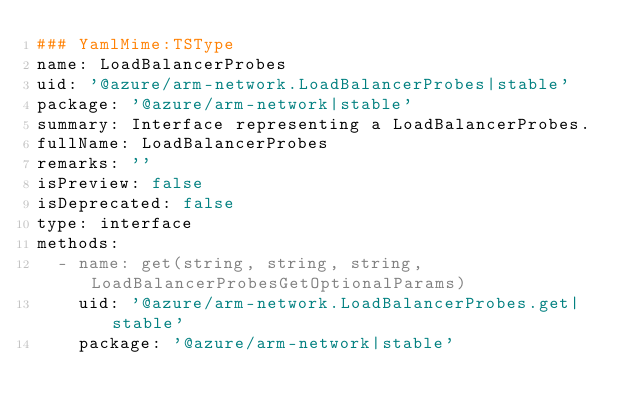Convert code to text. <code><loc_0><loc_0><loc_500><loc_500><_YAML_>### YamlMime:TSType
name: LoadBalancerProbes
uid: '@azure/arm-network.LoadBalancerProbes|stable'
package: '@azure/arm-network|stable'
summary: Interface representing a LoadBalancerProbes.
fullName: LoadBalancerProbes
remarks: ''
isPreview: false
isDeprecated: false
type: interface
methods:
  - name: get(string, string, string, LoadBalancerProbesGetOptionalParams)
    uid: '@azure/arm-network.LoadBalancerProbes.get|stable'
    package: '@azure/arm-network|stable'</code> 